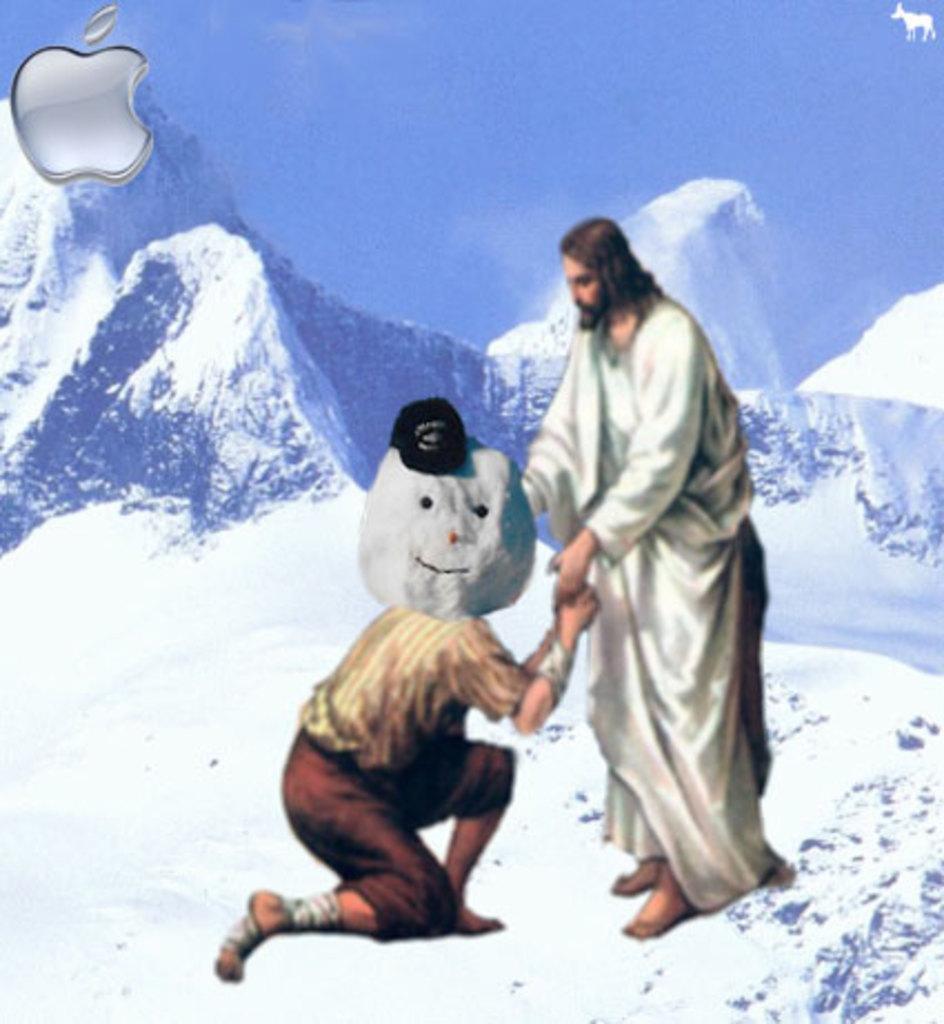How would you summarize this image in a sentence or two? In this image I can see the edited picture in which I can see a person wearing white colored dress is standing and and another person wearing brown colored dress is sitting. I can see a head which is made of snow and a black colored hat on it. In the background I can see few mountains with snow on them and the sky. 